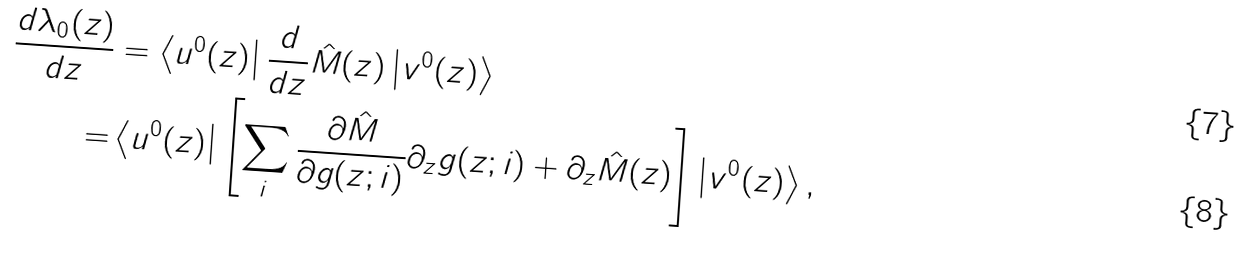<formula> <loc_0><loc_0><loc_500><loc_500>\frac { d \lambda _ { 0 } ( z ) } { d z } & = \left \langle u ^ { 0 } ( z ) \right | \frac { d } { d z } \hat { M } ( z ) \left | v ^ { 0 } ( z ) \right \rangle \\ = & \left \langle u ^ { 0 } ( z ) \right | \left [ \sum _ { i } \frac { \partial \hat { M } } { \partial g ( z ; i ) } \partial _ { z } g ( z ; i ) + \partial _ { z } \hat { M } ( z ) \right ] \left | v ^ { 0 } ( z ) \right \rangle ,</formula> 